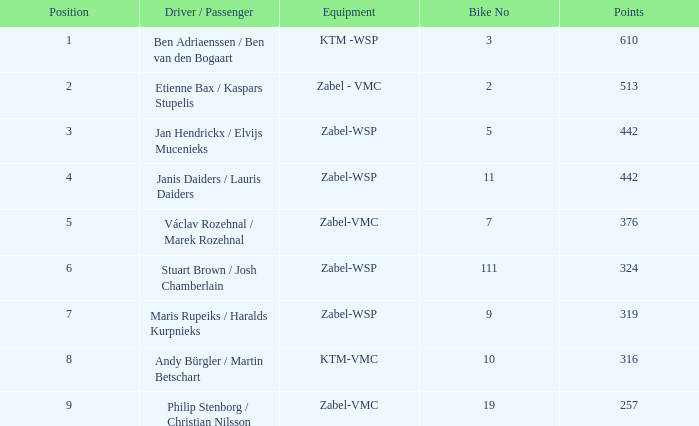What are the features of ktm-vmc equipment? 316.0. 